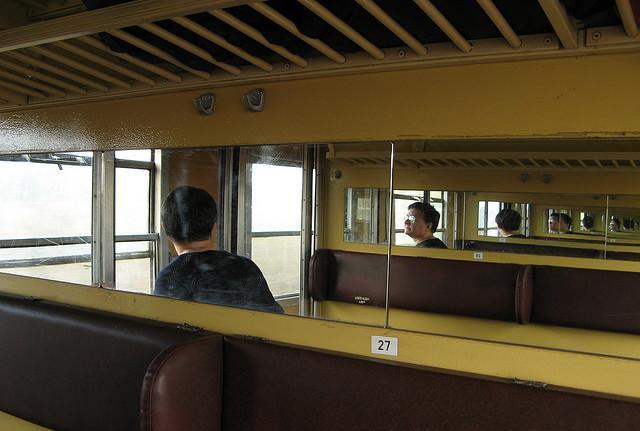How many people are sitting at tables in this room?
Give a very brief answer. 1. How many microwaves have a sticker?
Give a very brief answer. 0. 